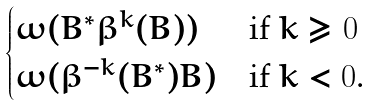<formula> <loc_0><loc_0><loc_500><loc_500>\begin{cases} \omega ( B ^ { * } \beta ^ { k } ( B ) ) & \text {if $k\geq 0$} \\ \omega ( \beta ^ { - k } ( B ^ { * } ) B ) & \text {if $k < 0$.} \end{cases}</formula> 